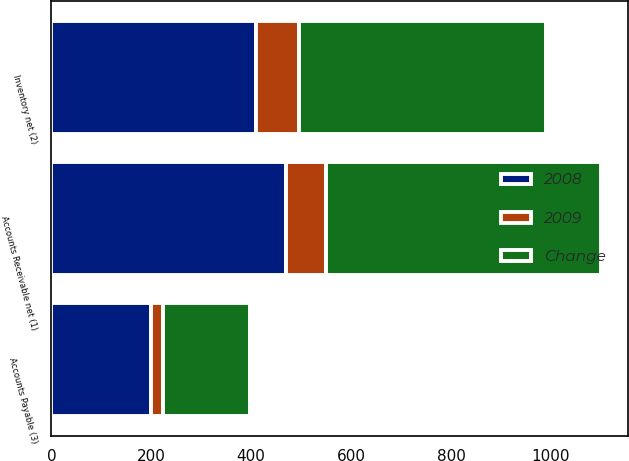Convert chart. <chart><loc_0><loc_0><loc_500><loc_500><stacked_bar_chart><ecel><fcel>Accounts Receivable net (1)<fcel>Inventory net (2)<fcel>Accounts Payable (3)<nl><fcel>2008<fcel>469<fcel>409<fcel>199<nl><fcel>Change<fcel>550<fcel>495<fcel>175<nl><fcel>2009<fcel>81<fcel>86<fcel>24<nl></chart> 